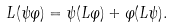Convert formula to latex. <formula><loc_0><loc_0><loc_500><loc_500>L ( \psi \varphi ) = \psi ( L \varphi ) + \varphi ( L \psi ) .</formula> 